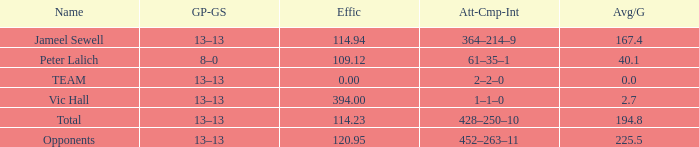Avg/G of 2.7 is what effic? 394.0. 